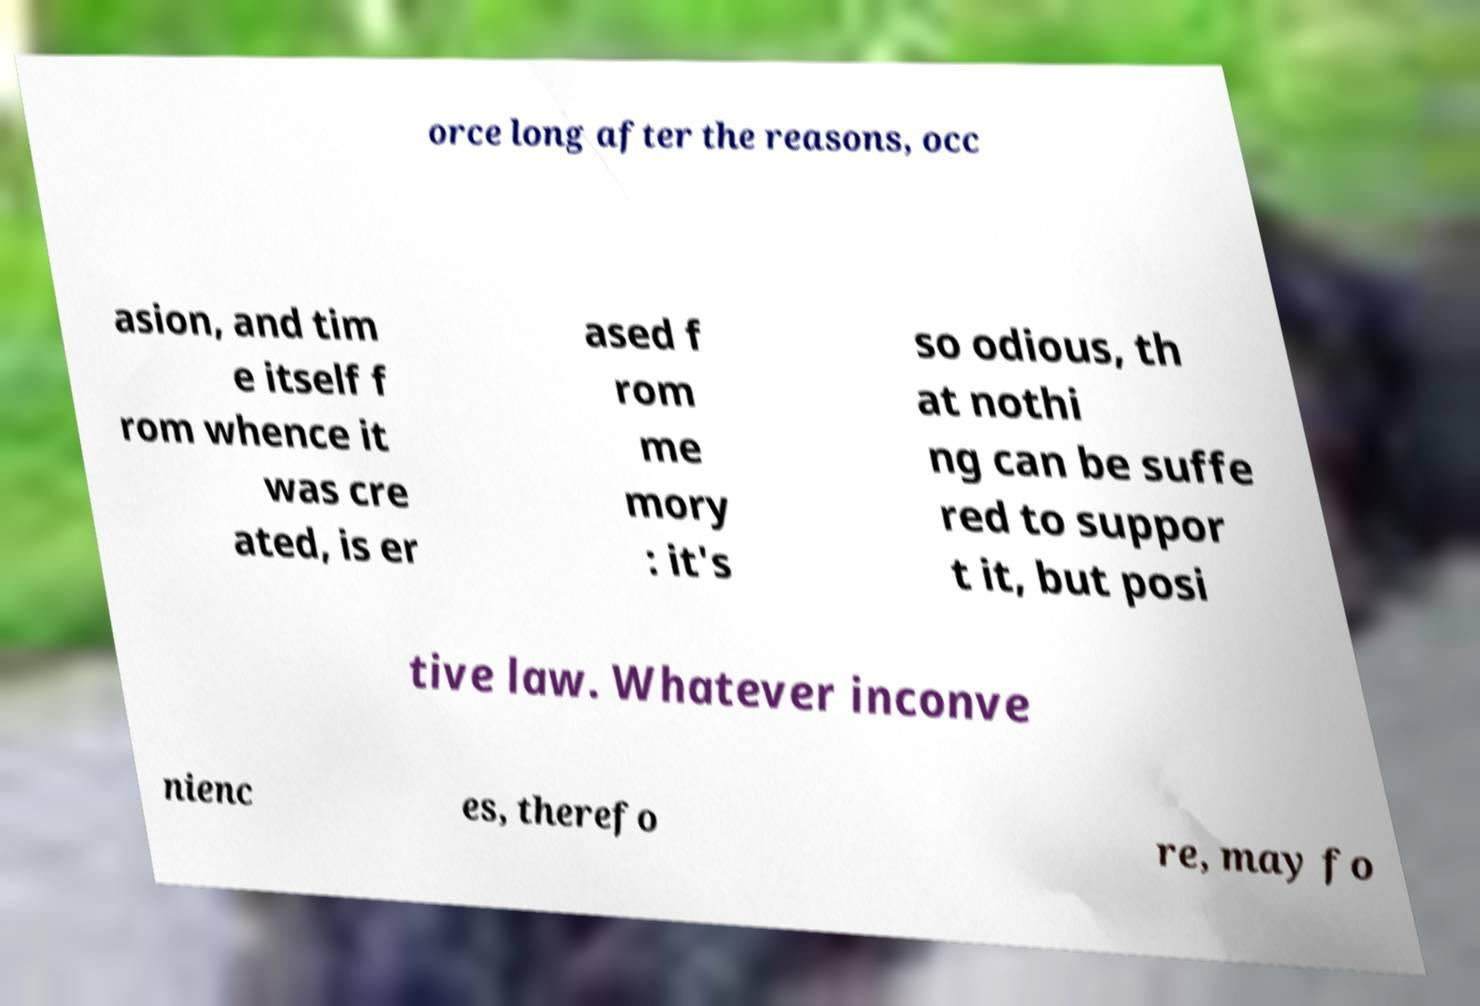Can you read and provide the text displayed in the image?This photo seems to have some interesting text. Can you extract and type it out for me? orce long after the reasons, occ asion, and tim e itself f rom whence it was cre ated, is er ased f rom me mory : it's so odious, th at nothi ng can be suffe red to suppor t it, but posi tive law. Whatever inconve nienc es, therefo re, may fo 